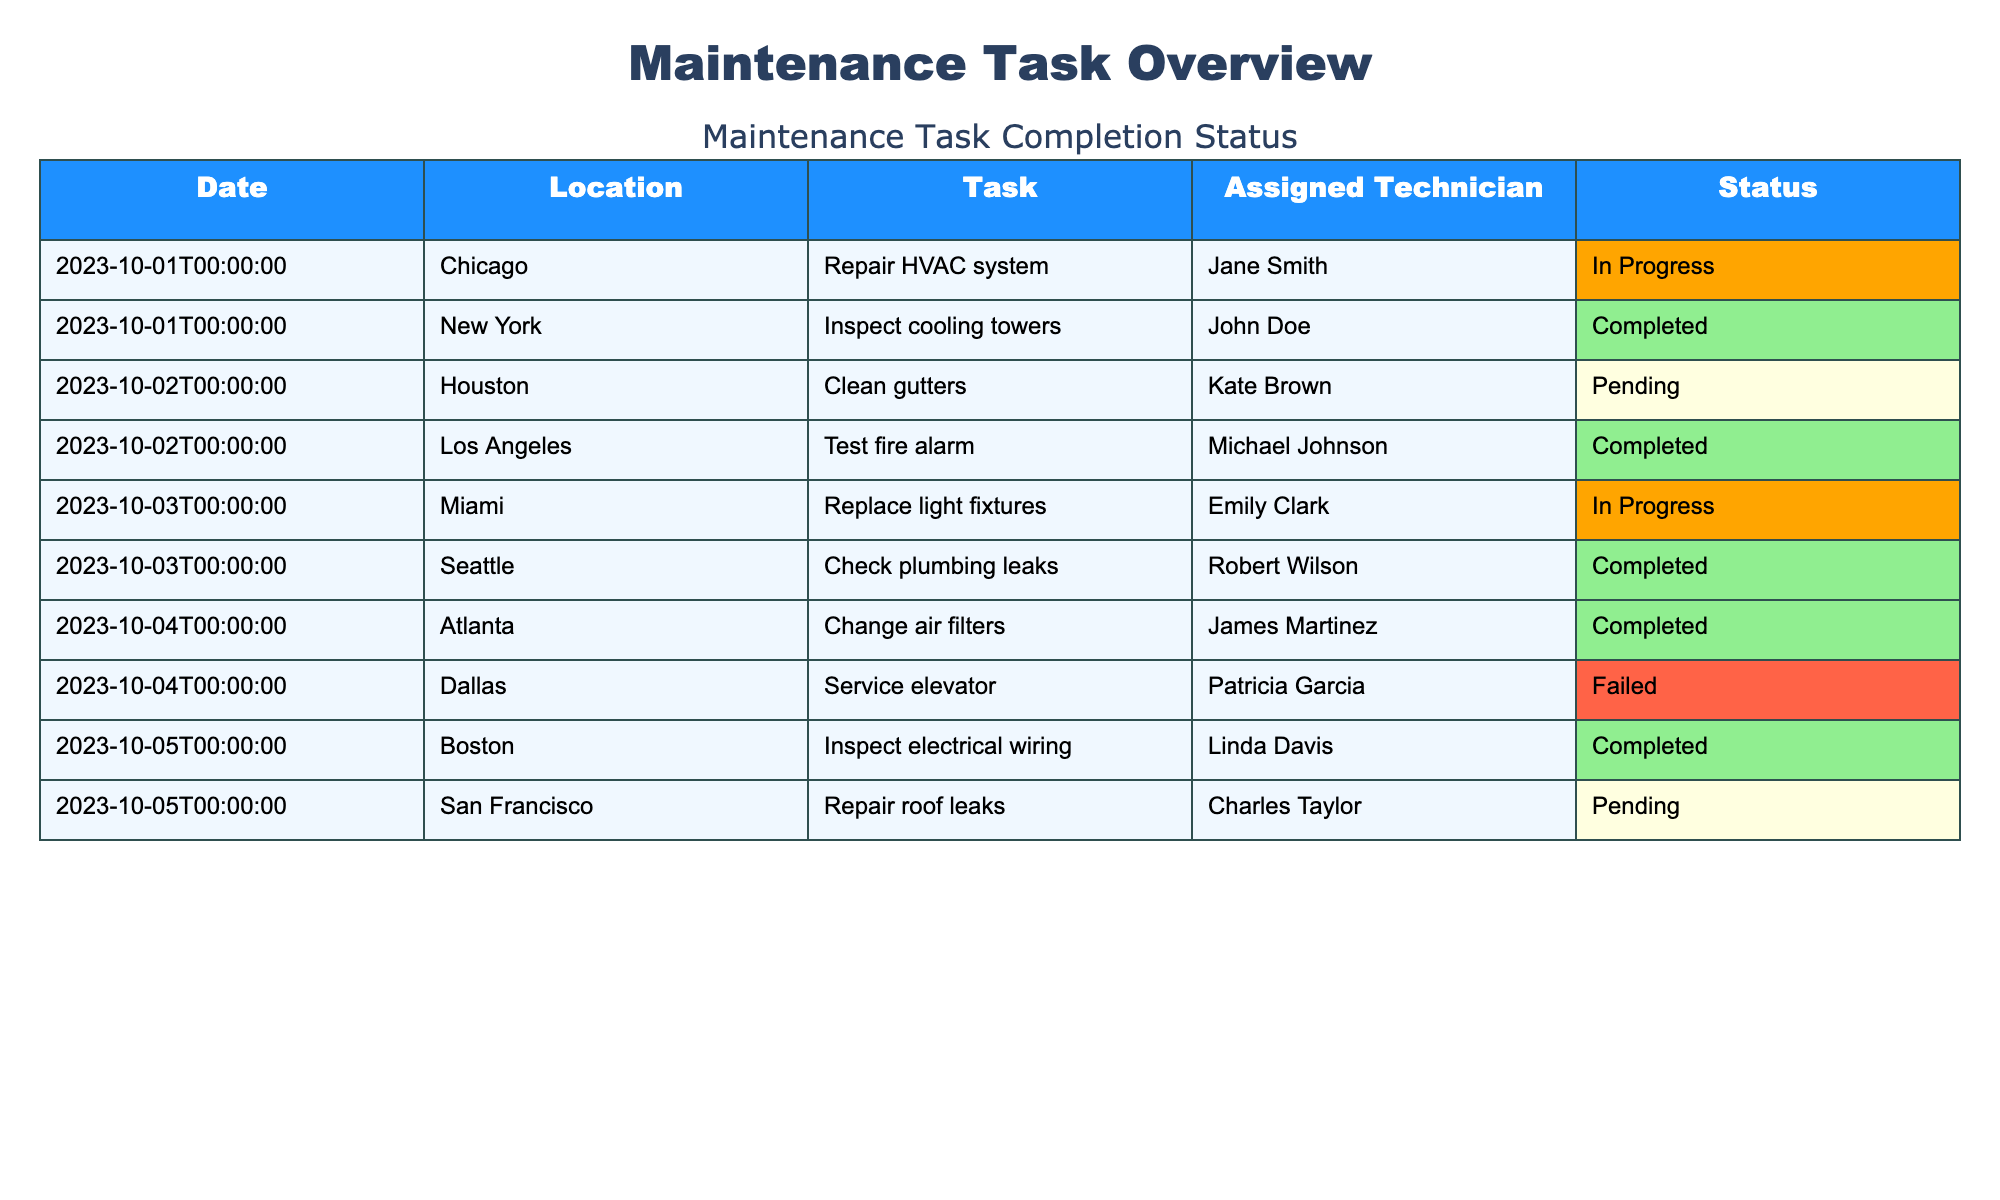What is the status of the maintenance task in Miami on October 3, 2023? The task on that date in Miami is to replace light fixtures, and its status is "In Progress."
Answer: In Progress How many tasks have been marked as "Completed"? By filtering the table for rows where the status is "Completed," I find four tasks: Inspect cooling towers, Test fire alarm, Change air filters, and Inspect electrical wiring. Therefore, there are four completed tasks.
Answer: 4 Is there any task marked as "Failed"? There is one task listed as "Failed," which is the service elevator task in Dallas on October 4, 2023.
Answer: Yes Which technician has the most tasks assigned on the table? The technicians are John Doe, Jane Smith, Michael Johnson, Kate Brown, Emily Clark, Robert Wilson, Patricia Garcia, James Martinez, and Linda Davis. Each technician has one task assigned except for Kate Brown, who has one task, as does every other technician. Hence, there is no technician with more than one assigned task.
Answer: No technician has more tasks What is the difference in the number of tasks between "Completed" and "Pending"? The number of "Completed" tasks is 4 (from New York, Los Angeles, Atlanta, and Boston), and the number of "Pending" tasks is 2 (from Houston and San Francisco). The difference is 4 - 2, which equals 2.
Answer: 2 